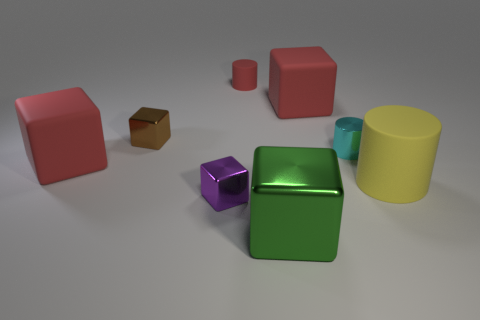Subtract 2 blocks. How many blocks are left? 3 Subtract all green blocks. How many blocks are left? 4 Subtract all large green shiny blocks. How many blocks are left? 4 Add 1 large yellow spheres. How many objects exist? 9 Subtract all purple cubes. Subtract all green cylinders. How many cubes are left? 4 Subtract all cylinders. How many objects are left? 5 Add 7 red cylinders. How many red cylinders exist? 8 Subtract 1 green cubes. How many objects are left? 7 Subtract all rubber cubes. Subtract all metallic objects. How many objects are left? 2 Add 6 brown objects. How many brown objects are left? 7 